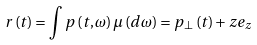<formula> <loc_0><loc_0><loc_500><loc_500>r \left ( t \right ) = \int p \left ( t , \omega \right ) \mu \left ( d \omega \right ) = p _ { \bot } \left ( t \right ) + z e _ { z }</formula> 